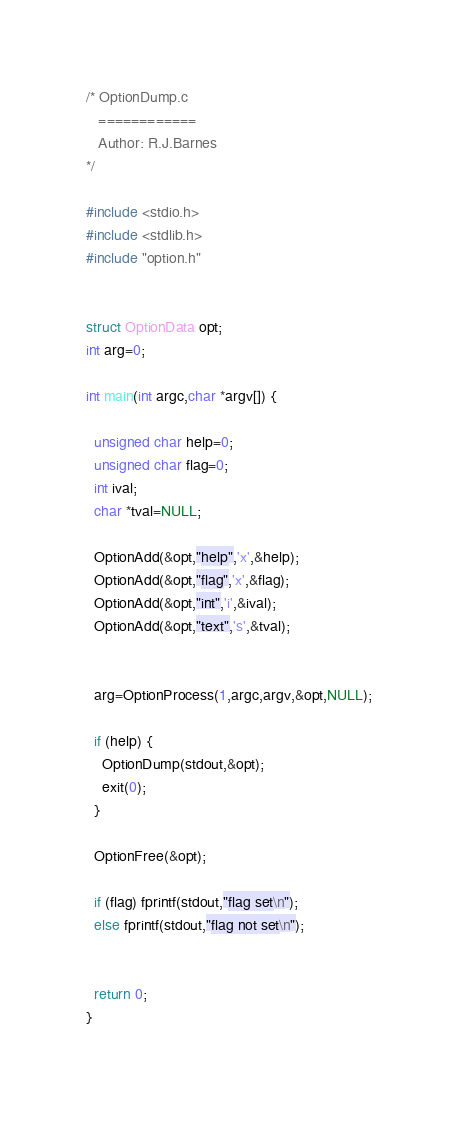<code> <loc_0><loc_0><loc_500><loc_500><_C_>/* OptionDump.c
   ============
   Author: R.J.Barnes
*/

#include <stdio.h>
#include <stdlib.h>
#include "option.h"


struct OptionData opt;
int arg=0;

int main(int argc,char *argv[]) {

  unsigned char help=0;
  unsigned char flag=0;
  int ival;
  char *tval=NULL;

  OptionAdd(&opt,"help",'x',&help);
  OptionAdd(&opt,"flag",'x',&flag); 
  OptionAdd(&opt,"int",'i',&ival); 
  OptionAdd(&opt,"text",'s',&tval); 


  arg=OptionProcess(1,argc,argv,&opt,NULL);

  if (help) {
    OptionDump(stdout,&opt);
    exit(0);
  }

  OptionFree(&opt);

  if (flag) fprintf(stdout,"flag set\n");
  else fprintf(stdout,"flag not set\n");
 
 
  return 0;
}
   


</code> 